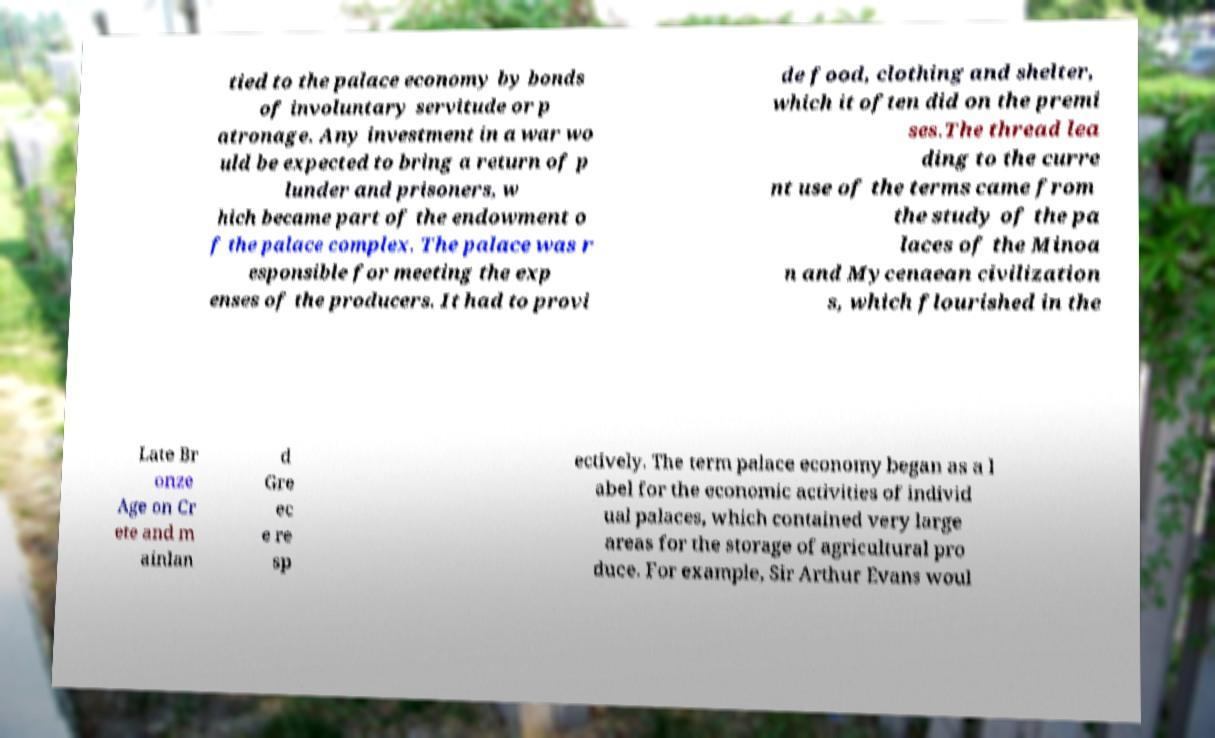Could you extract and type out the text from this image? tied to the palace economy by bonds of involuntary servitude or p atronage. Any investment in a war wo uld be expected to bring a return of p lunder and prisoners, w hich became part of the endowment o f the palace complex. The palace was r esponsible for meeting the exp enses of the producers. It had to provi de food, clothing and shelter, which it often did on the premi ses.The thread lea ding to the curre nt use of the terms came from the study of the pa laces of the Minoa n and Mycenaean civilization s, which flourished in the Late Br onze Age on Cr ete and m ainlan d Gre ec e re sp ectively. The term palace economy began as a l abel for the economic activities of individ ual palaces, which contained very large areas for the storage of agricultural pro duce. For example, Sir Arthur Evans woul 